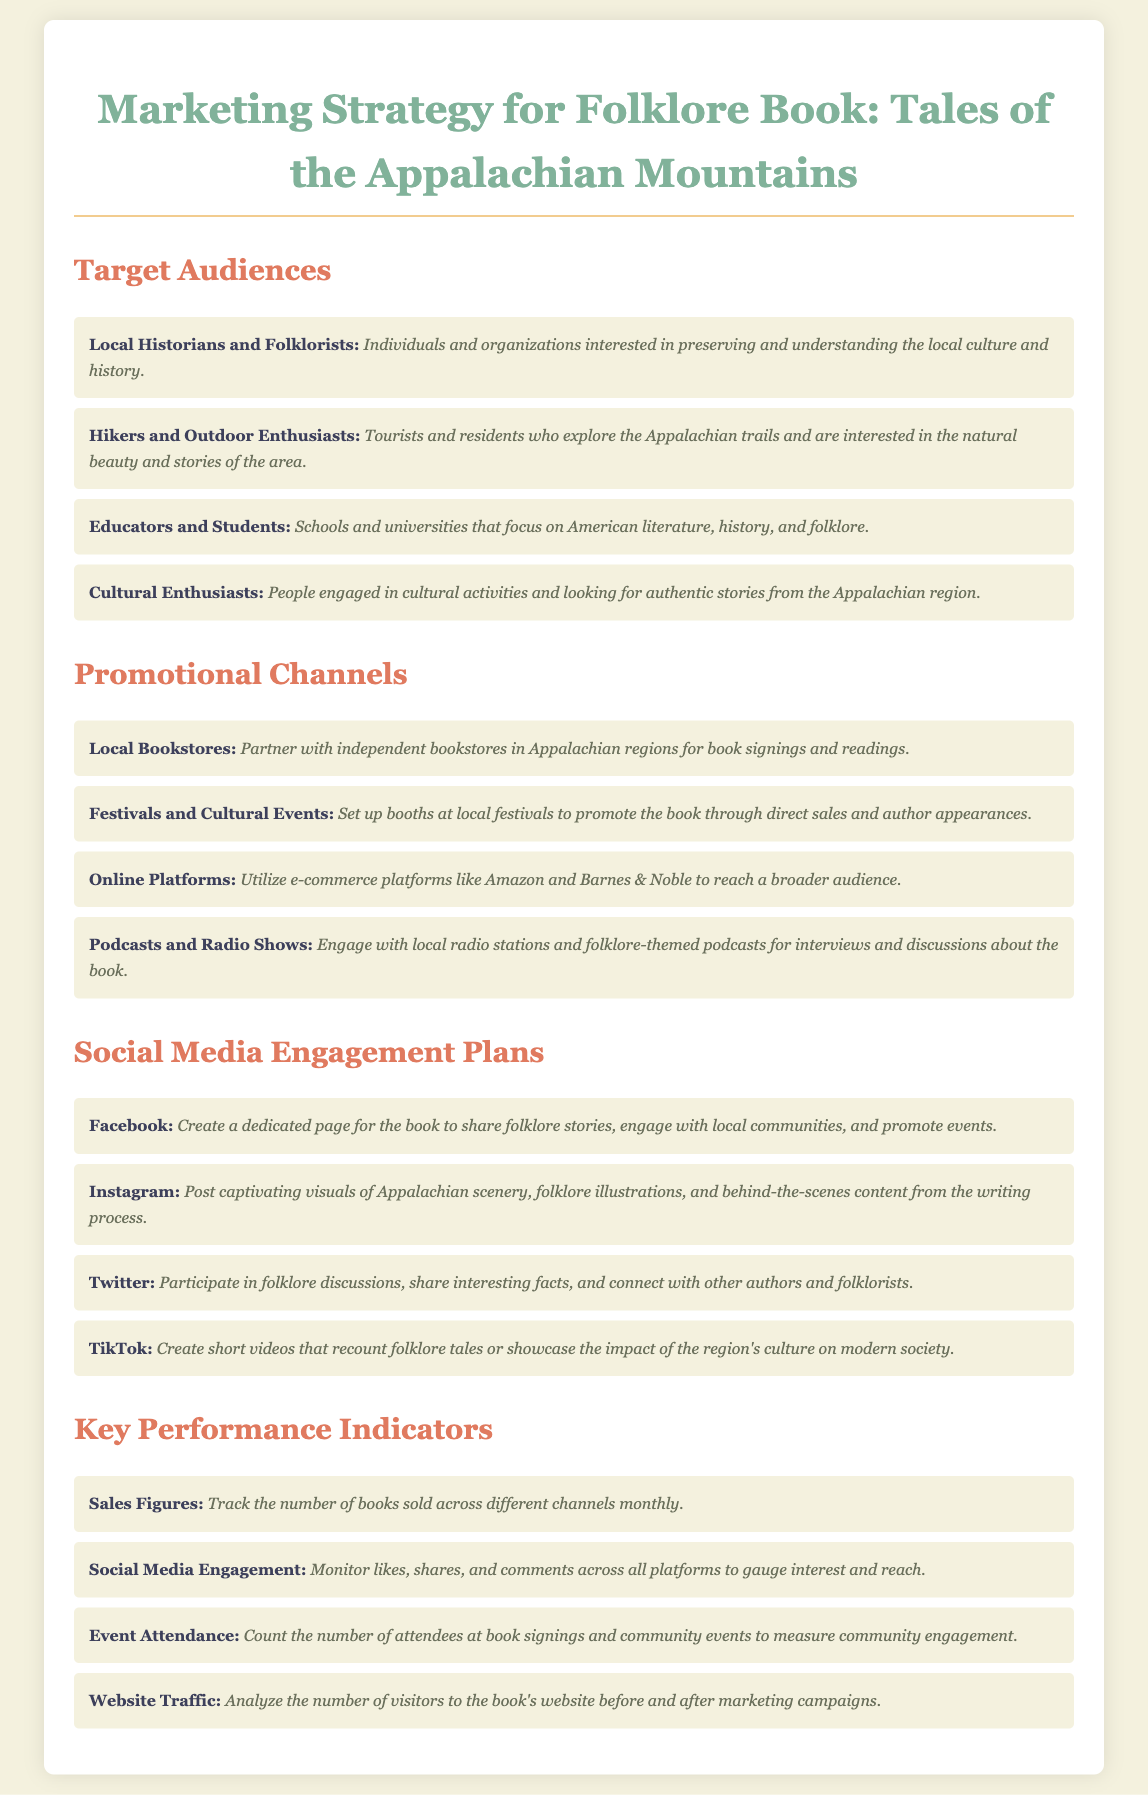What are the target audiences for the folklore book? The target audiences are local historians and folklorists, hikers and outdoor enthusiasts, educators and students, and cultural enthusiasts.
Answer: Local historians and folklorists, hikers and outdoor enthusiasts, educators and students, cultural enthusiasts How many promotional channels are listed in the document? The document lists four promotional channels for the folklore book.
Answer: Four What is one social media platform mentioned for engagement? The document includes several social media platforms for engagement; one of them is Facebook.
Answer: Facebook What is the first key performance indicator? The first key performance indicator mentioned in the document is sales figures.
Answer: Sales figures Which channel involves local festivals? The promotional channel that involves local festivals is festivals and cultural events.
Answer: Festivals and cultural events What type of audiences are educators and students classified as? Educators and students are classified as a target audience interested in American literature, history, and folklore.
Answer: Target audience How many social media platforms are outlined in the engagement plans? The document describes four social media platforms for engagement.
Answer: Four What type of events will the author engage in for promotions? The author will participate in book signings and community events.
Answer: Book signings and community events 